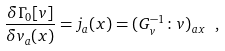<formula> <loc_0><loc_0><loc_500><loc_500>\frac { \delta \Gamma _ { 0 } [ v ] } { \delta v _ { a } ( x ) } = j _ { a } ( x ) = ( G _ { v } ^ { - 1 } \colon v ) _ { a x } \ ,</formula> 